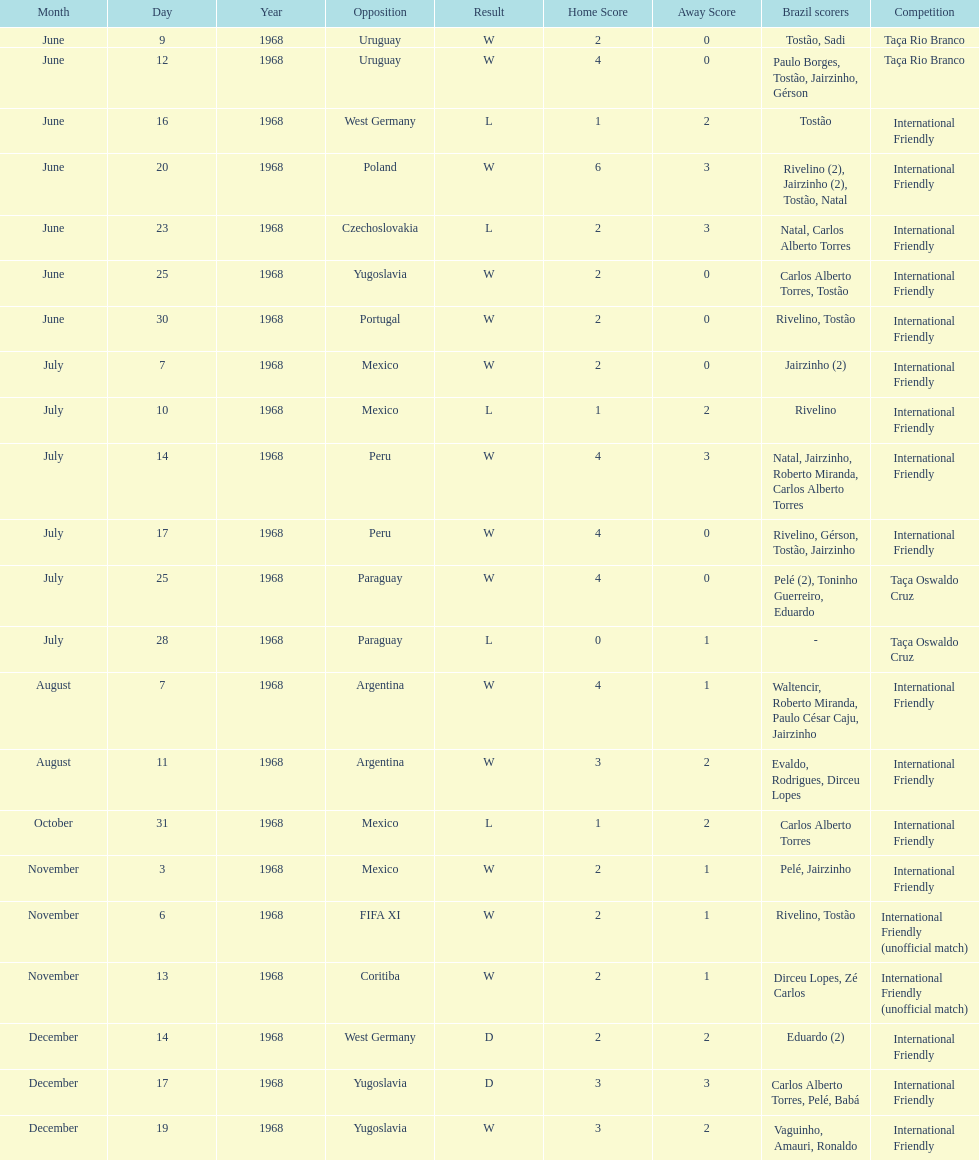Number of losses 5. 